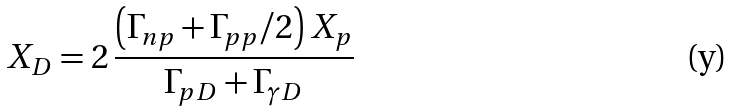Convert formula to latex. <formula><loc_0><loc_0><loc_500><loc_500>X _ { D } = 2 \, \frac { \left ( \Gamma _ { n p } + \Gamma _ { p p } / 2 \right ) X _ { p } } { \Gamma _ { p D } + \Gamma _ { \gamma D } }</formula> 